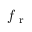<formula> <loc_0><loc_0><loc_500><loc_500>f _ { r }</formula> 